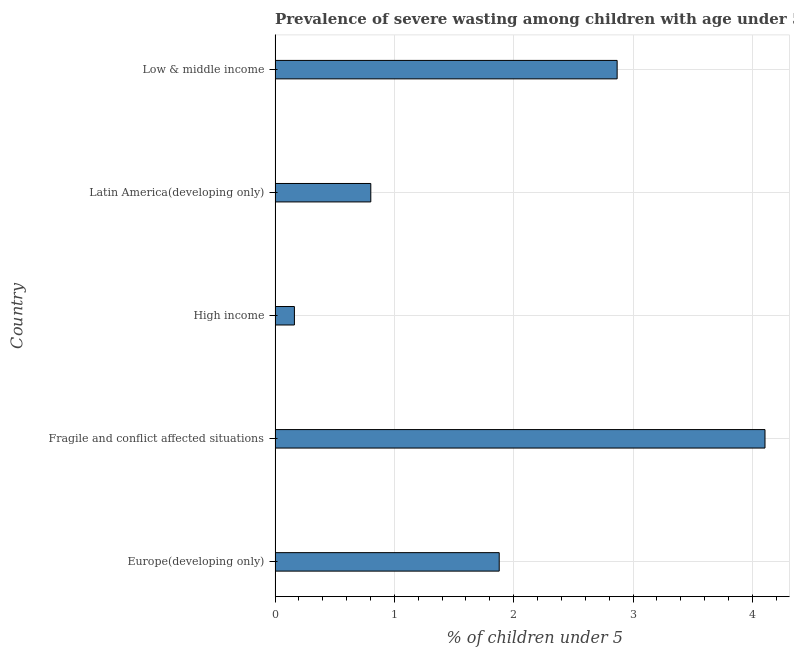Does the graph contain any zero values?
Offer a terse response. No. What is the title of the graph?
Keep it short and to the point. Prevalence of severe wasting among children with age under 5 years in 1995. What is the label or title of the X-axis?
Ensure brevity in your answer.   % of children under 5. What is the label or title of the Y-axis?
Provide a short and direct response. Country. What is the prevalence of severe wasting in Fragile and conflict affected situations?
Offer a very short reply. 4.11. Across all countries, what is the maximum prevalence of severe wasting?
Your response must be concise. 4.11. Across all countries, what is the minimum prevalence of severe wasting?
Keep it short and to the point. 0.16. In which country was the prevalence of severe wasting maximum?
Provide a short and direct response. Fragile and conflict affected situations. What is the sum of the prevalence of severe wasting?
Offer a very short reply. 9.82. What is the difference between the prevalence of severe wasting in Europe(developing only) and High income?
Make the answer very short. 1.72. What is the average prevalence of severe wasting per country?
Offer a terse response. 1.96. What is the median prevalence of severe wasting?
Provide a short and direct response. 1.88. In how many countries, is the prevalence of severe wasting greater than 3.4 %?
Provide a short and direct response. 1. What is the ratio of the prevalence of severe wasting in Europe(developing only) to that in Latin America(developing only)?
Make the answer very short. 2.34. Is the prevalence of severe wasting in Fragile and conflict affected situations less than that in Latin America(developing only)?
Give a very brief answer. No. Is the difference between the prevalence of severe wasting in Fragile and conflict affected situations and Low & middle income greater than the difference between any two countries?
Make the answer very short. No. What is the difference between the highest and the second highest prevalence of severe wasting?
Offer a terse response. 1.24. Is the sum of the prevalence of severe wasting in Europe(developing only) and Fragile and conflict affected situations greater than the maximum prevalence of severe wasting across all countries?
Provide a short and direct response. Yes. What is the difference between the highest and the lowest prevalence of severe wasting?
Your answer should be very brief. 3.94. In how many countries, is the prevalence of severe wasting greater than the average prevalence of severe wasting taken over all countries?
Give a very brief answer. 2. How many bars are there?
Keep it short and to the point. 5. Are all the bars in the graph horizontal?
Make the answer very short. Yes. What is the difference between two consecutive major ticks on the X-axis?
Keep it short and to the point. 1. Are the values on the major ticks of X-axis written in scientific E-notation?
Make the answer very short. No. What is the  % of children under 5 of Europe(developing only)?
Offer a very short reply. 1.88. What is the  % of children under 5 of Fragile and conflict affected situations?
Give a very brief answer. 4.11. What is the  % of children under 5 of High income?
Offer a very short reply. 0.16. What is the  % of children under 5 of Latin America(developing only)?
Your answer should be very brief. 0.8. What is the  % of children under 5 of Low & middle income?
Make the answer very short. 2.87. What is the difference between the  % of children under 5 in Europe(developing only) and Fragile and conflict affected situations?
Offer a very short reply. -2.23. What is the difference between the  % of children under 5 in Europe(developing only) and High income?
Offer a terse response. 1.72. What is the difference between the  % of children under 5 in Europe(developing only) and Latin America(developing only)?
Your answer should be compact. 1.08. What is the difference between the  % of children under 5 in Europe(developing only) and Low & middle income?
Make the answer very short. -0.99. What is the difference between the  % of children under 5 in Fragile and conflict affected situations and High income?
Your answer should be very brief. 3.94. What is the difference between the  % of children under 5 in Fragile and conflict affected situations and Latin America(developing only)?
Provide a short and direct response. 3.3. What is the difference between the  % of children under 5 in Fragile and conflict affected situations and Low & middle income?
Offer a terse response. 1.24. What is the difference between the  % of children under 5 in High income and Latin America(developing only)?
Provide a succinct answer. -0.64. What is the difference between the  % of children under 5 in High income and Low & middle income?
Provide a succinct answer. -2.71. What is the difference between the  % of children under 5 in Latin America(developing only) and Low & middle income?
Offer a terse response. -2.06. What is the ratio of the  % of children under 5 in Europe(developing only) to that in Fragile and conflict affected situations?
Give a very brief answer. 0.46. What is the ratio of the  % of children under 5 in Europe(developing only) to that in High income?
Your response must be concise. 11.6. What is the ratio of the  % of children under 5 in Europe(developing only) to that in Latin America(developing only)?
Offer a very short reply. 2.34. What is the ratio of the  % of children under 5 in Europe(developing only) to that in Low & middle income?
Your answer should be compact. 0.66. What is the ratio of the  % of children under 5 in Fragile and conflict affected situations to that in High income?
Give a very brief answer. 25.36. What is the ratio of the  % of children under 5 in Fragile and conflict affected situations to that in Latin America(developing only)?
Ensure brevity in your answer.  5.12. What is the ratio of the  % of children under 5 in Fragile and conflict affected situations to that in Low & middle income?
Give a very brief answer. 1.43. What is the ratio of the  % of children under 5 in High income to that in Latin America(developing only)?
Ensure brevity in your answer.  0.2. What is the ratio of the  % of children under 5 in High income to that in Low & middle income?
Your answer should be very brief. 0.06. What is the ratio of the  % of children under 5 in Latin America(developing only) to that in Low & middle income?
Provide a short and direct response. 0.28. 